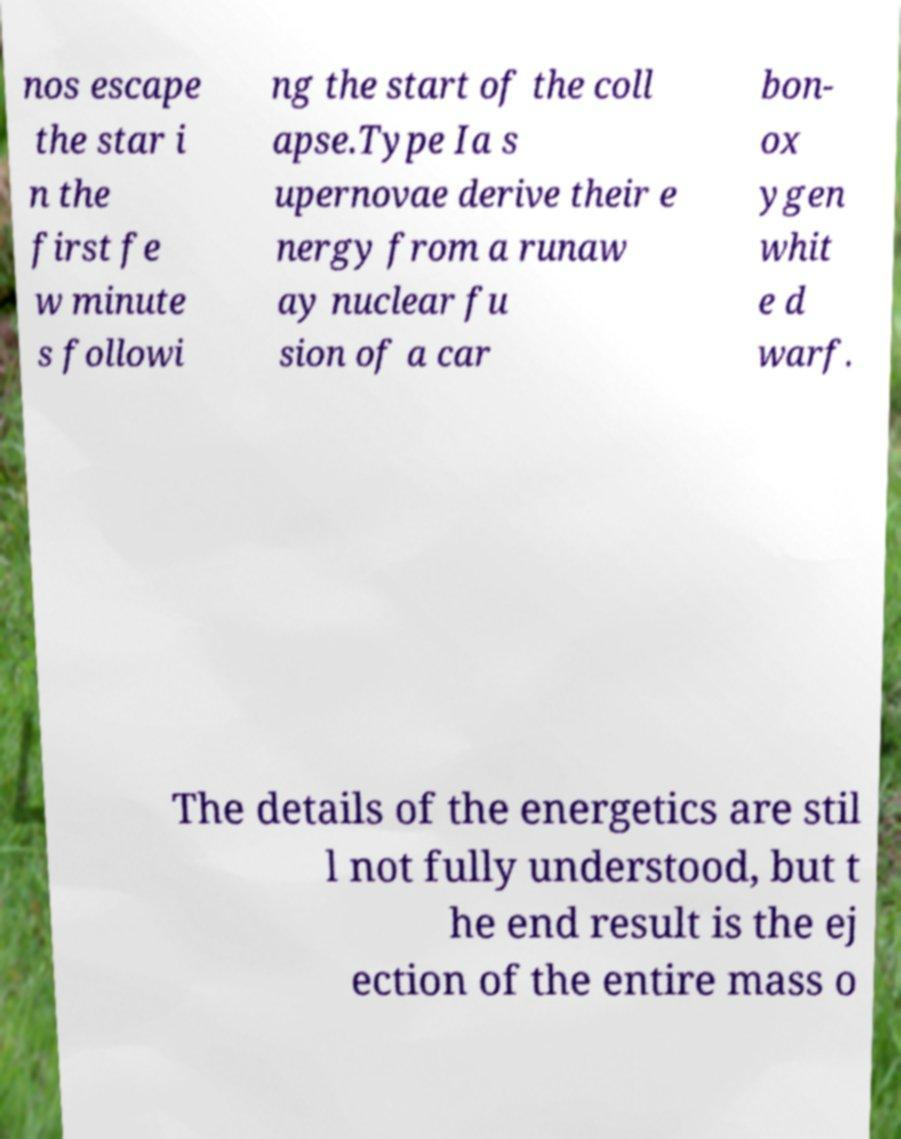Please identify and transcribe the text found in this image. nos escape the star i n the first fe w minute s followi ng the start of the coll apse.Type Ia s upernovae derive their e nergy from a runaw ay nuclear fu sion of a car bon- ox ygen whit e d warf. The details of the energetics are stil l not fully understood, but t he end result is the ej ection of the entire mass o 